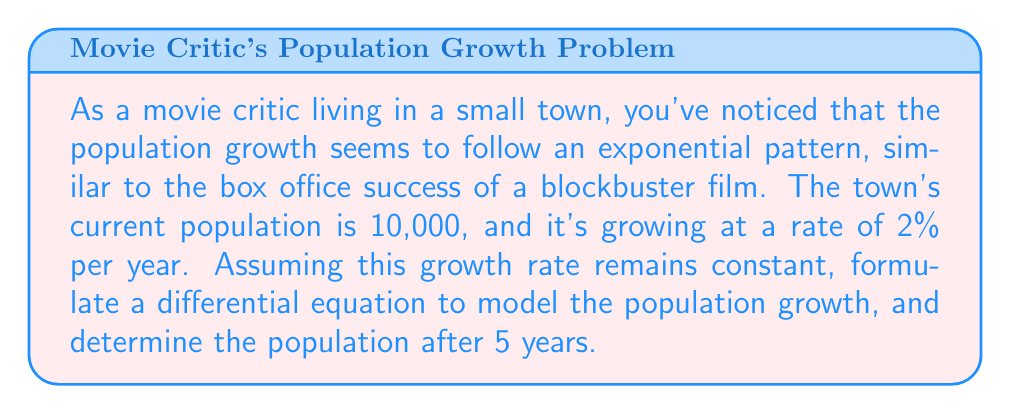Could you help me with this problem? Let's approach this step-by-step:

1) Let $P(t)$ be the population at time $t$, where $t$ is measured in years.

2) The rate of change of the population is proportional to the current population. This can be expressed as:

   $$\frac{dP}{dt} = kP$$

   where $k$ is the growth rate constant.

3) We're given that the growth rate is 2% per year, so $k = 0.02$.

4) Our differential equation becomes:

   $$\frac{dP}{dt} = 0.02P$$

5) This is a separable differential equation. We can solve it as follows:

   $$\frac{dP}{P} = 0.02dt$$

6) Integrating both sides:

   $$\int \frac{dP}{P} = \int 0.02dt$$
   $$\ln|P| = 0.02t + C$$

7) Taking the exponential of both sides:

   $$P = e^{0.02t + C} = e^C \cdot e^{0.02t}$$

8) Let $A = e^C$. Then our general solution is:

   $$P(t) = Ae^{0.02t}$$

9) We can find $A$ using the initial condition. At $t=0$, $P(0) = 10,000$:

   $$10,000 = Ae^{0.02 \cdot 0} = A$$

10) Therefore, our particular solution is:

    $$P(t) = 10,000e^{0.02t}$$

11) To find the population after 5 years, we calculate $P(5)$:

    $$P(5) = 10,000e^{0.02 \cdot 5} = 10,000e^{0.1} \approx 11,051.71$$
Answer: The population after 5 years will be approximately 11,052 people. 